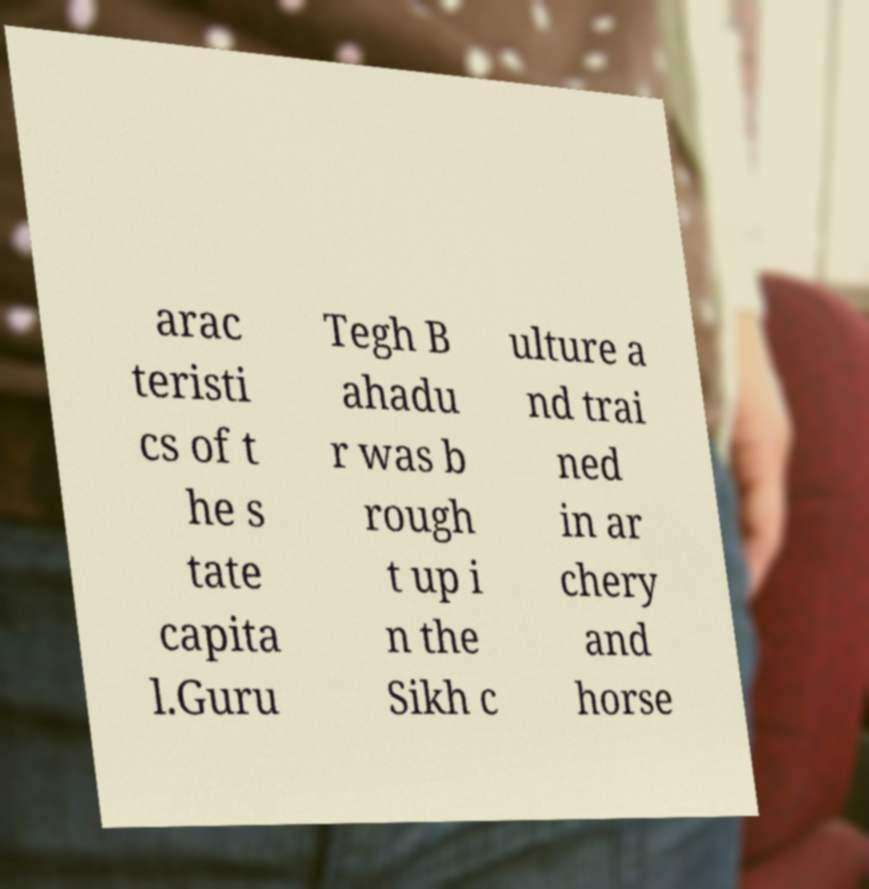For documentation purposes, I need the text within this image transcribed. Could you provide that? arac teristi cs of t he s tate capita l.Guru Tegh B ahadu r was b rough t up i n the Sikh c ulture a nd trai ned in ar chery and horse 